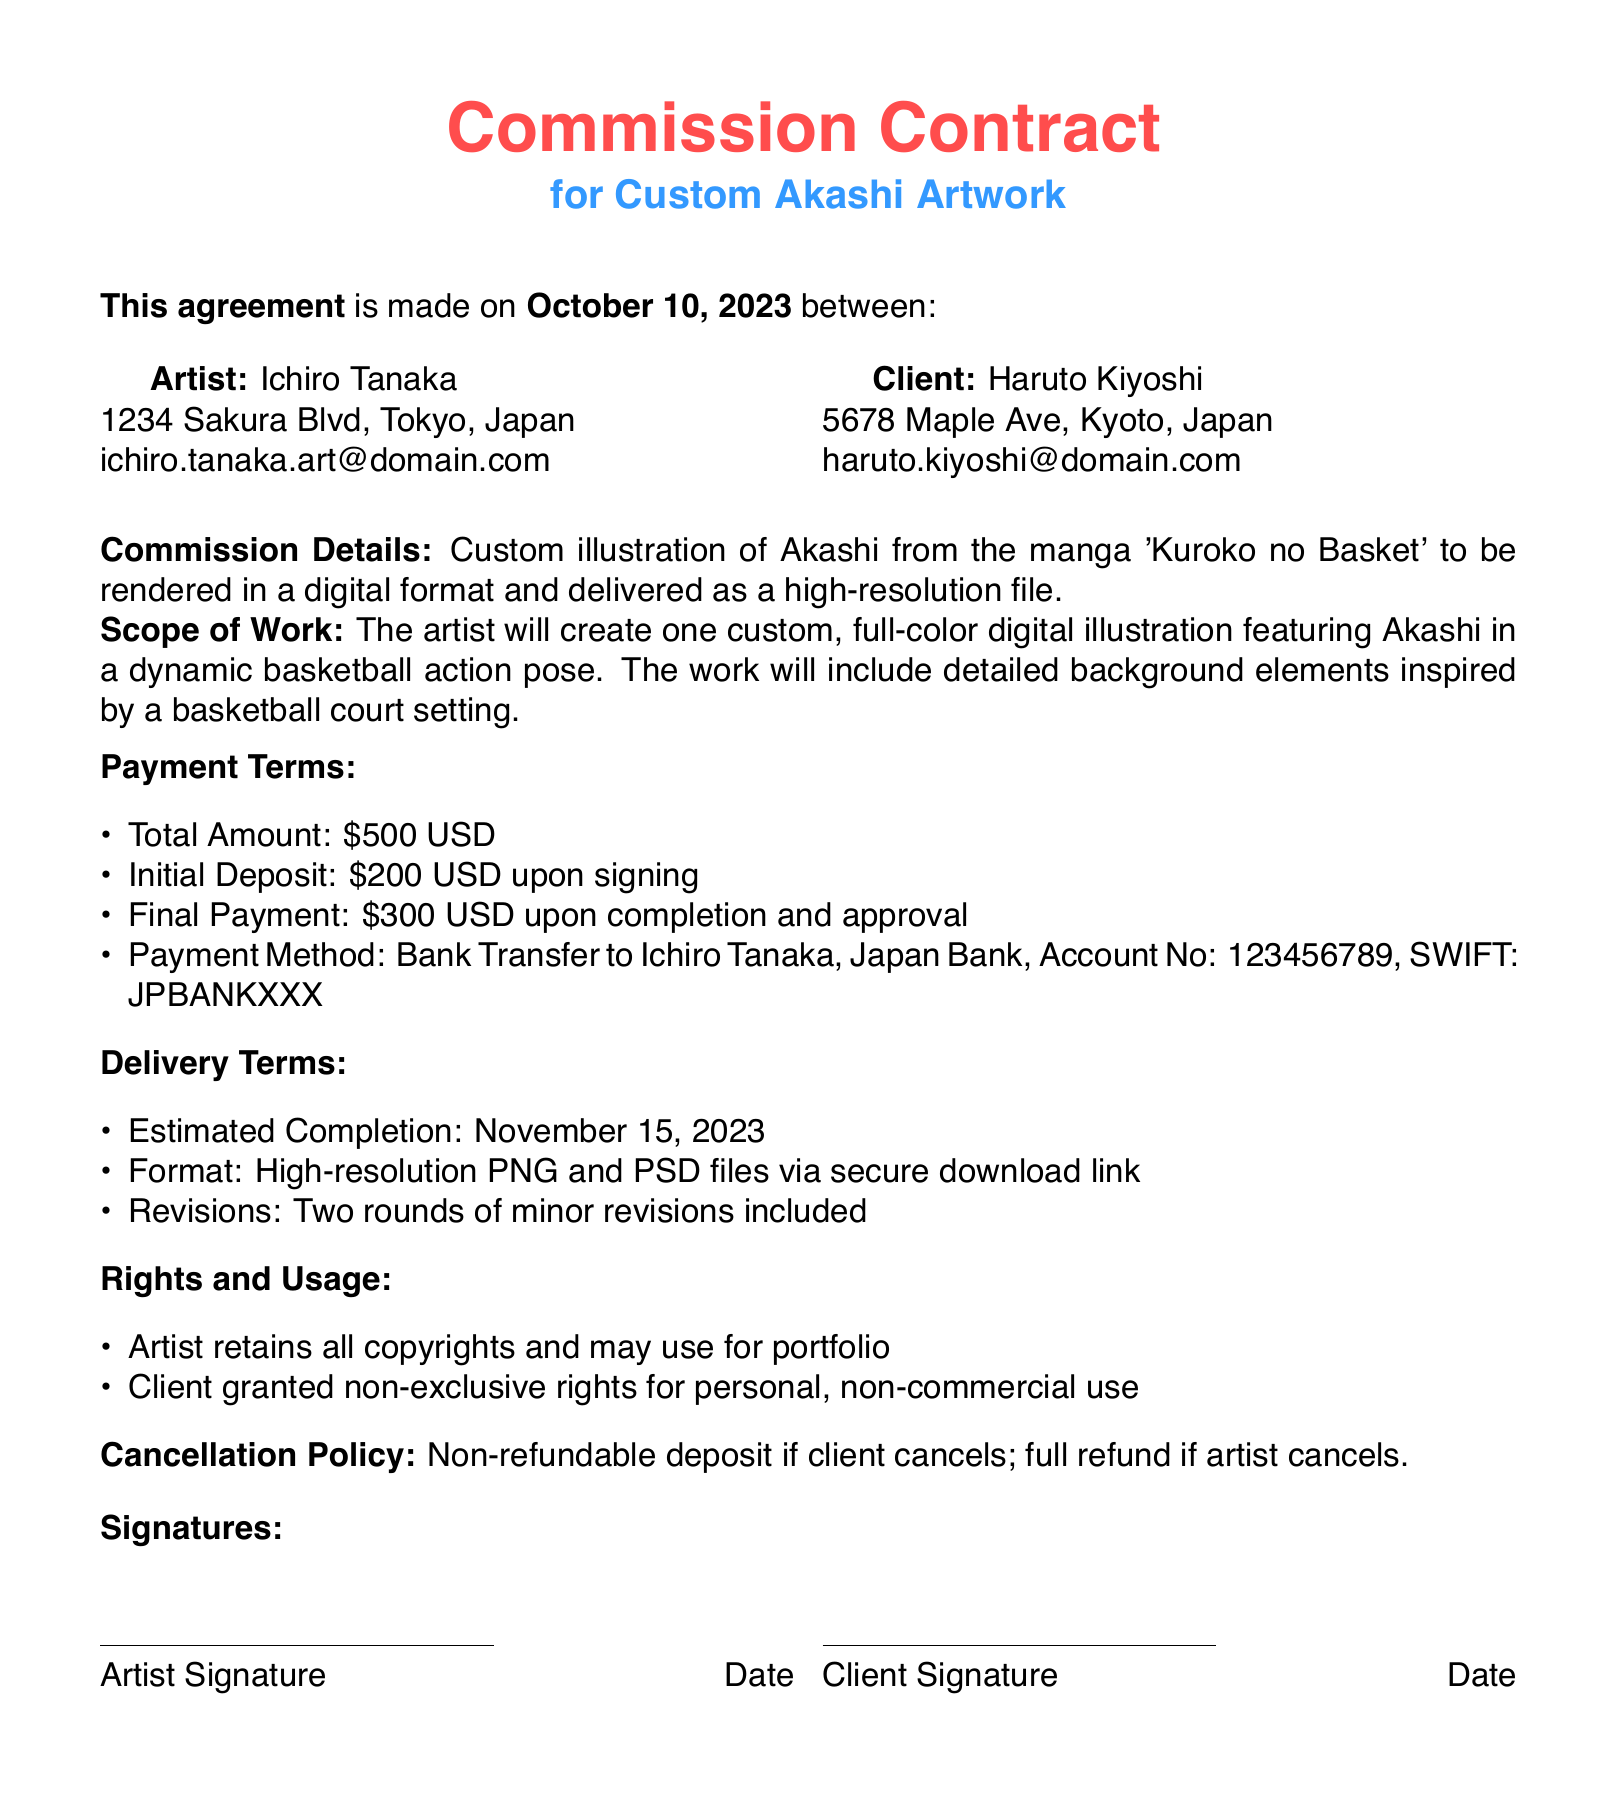What is the artist's name? The artist's name is listed at the beginning of the document.
Answer: Ichiro Tanaka What is the total amount for the commission? The total amount is specified in the payment terms section of the document.
Answer: $500 USD What is the client's email address? The client's email address is provided under the client's information.
Answer: haruto.kiyoshi@domain.com When is the estimated completion date? The estimated completion date is mentioned in the delivery terms section.
Answer: November 15, 2023 How many revisions are included in the commission? The number of revisions is stated in the delivery terms section of the document.
Answer: Two What rights does the artist retain? The rights retained by the artist are listed under the rights and usage section.
Answer: All copyrights What is the initial deposit amount? The initial deposit amount is detailed in the payment terms section.
Answer: $200 USD What are the payment methods available? The payment methods are specified under the payment terms section of the document.
Answer: Bank Transfer What happens if the client cancels? The cancellation policy explains the consequence of client cancellation.
Answer: Non-refundable deposit 